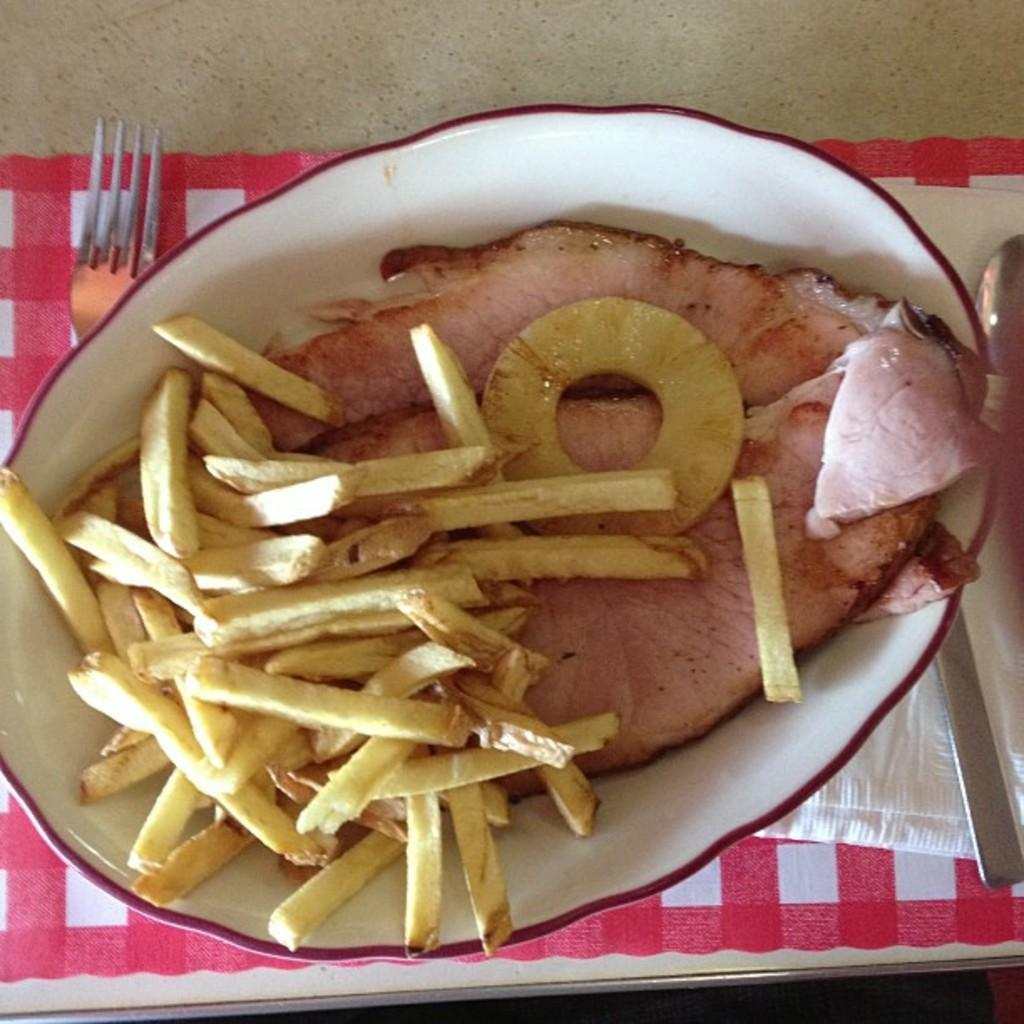What is in the bowl that is visible in the image? There are food items in a bowl in the image. What utensils are visible beside the bowl in the image? There are spoons beside the bowl in the image. What type of utensil is placed on the cloth in the image? There is a fork on the cloth in the image. Where is the cloth located in the image? The cloth is placed on a table in the image. What type of yarn is being used to create the fork's handle in the image? There is no yarn present in the image, and the fork's handle is not made of yarn. 